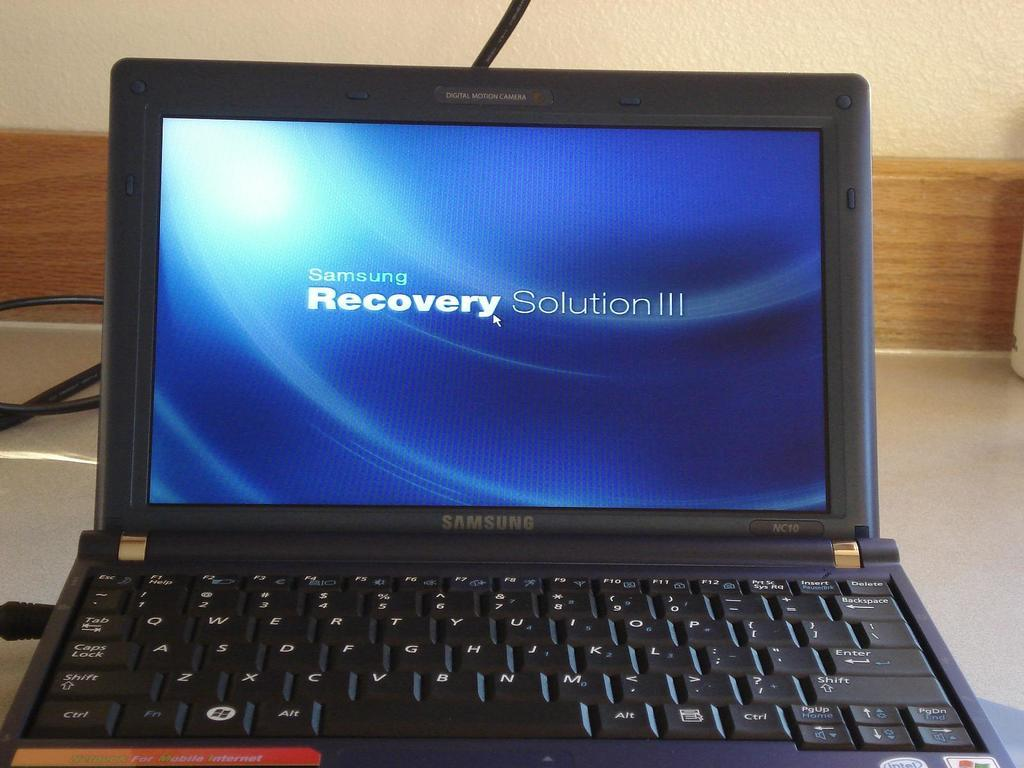Provide a one-sentence caption for the provided image. A laptop made by Samsung says Samsung Recovery Solution III. 